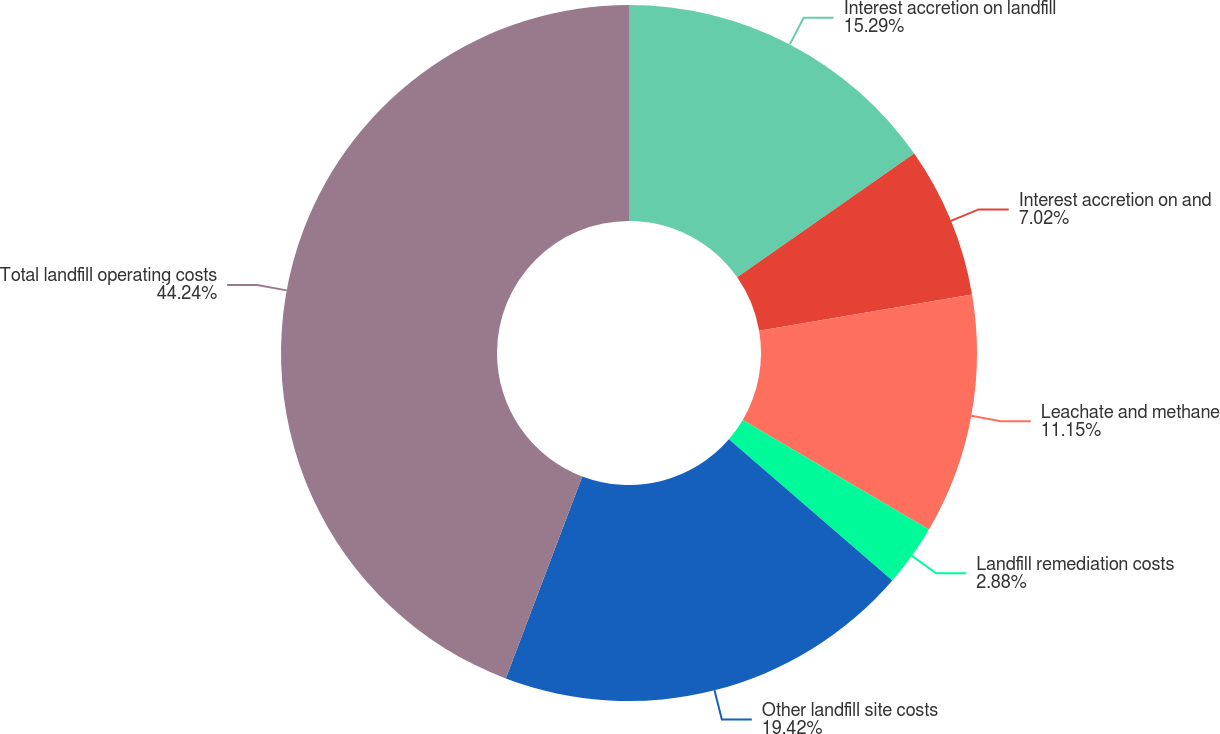<chart> <loc_0><loc_0><loc_500><loc_500><pie_chart><fcel>Interest accretion on landfill<fcel>Interest accretion on and<fcel>Leachate and methane<fcel>Landfill remediation costs<fcel>Other landfill site costs<fcel>Total landfill operating costs<nl><fcel>15.29%<fcel>7.02%<fcel>11.15%<fcel>2.88%<fcel>19.42%<fcel>44.24%<nl></chart> 